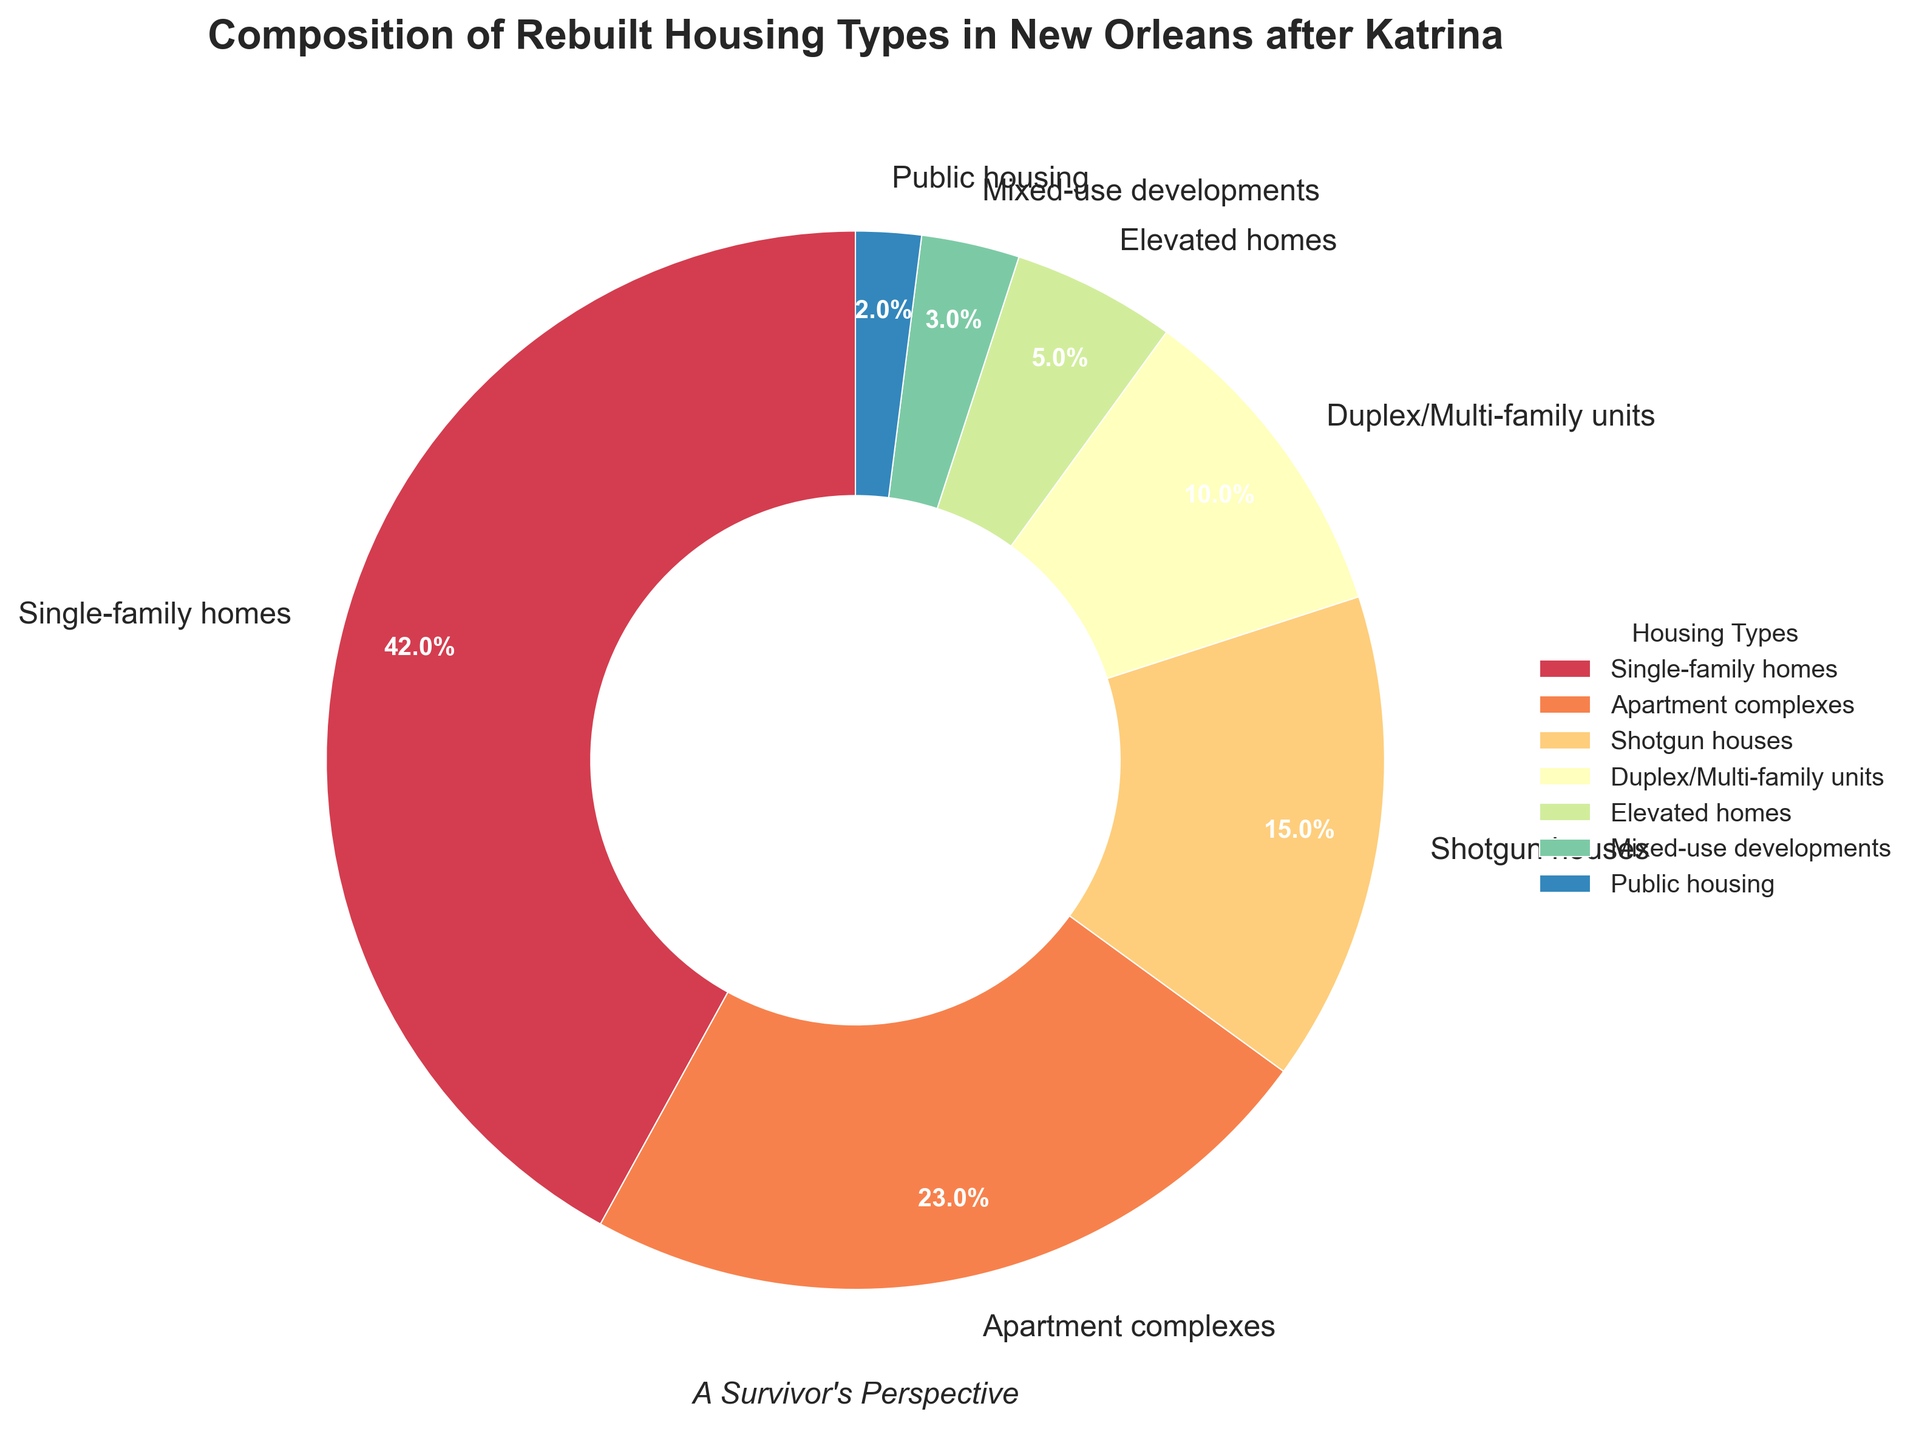Do single-family homes have a higher percentage than apartment complexes? To answer this, check the wedges labeled "Single-family homes" and "Apartment complexes." The percentage for single-family homes is 42%, while apartment complexes are at 23%. Since 42% is greater than 23%, single-family homes have a higher percentage.
Answer: Yes What's the combined percentage of Shotgun houses and Duplex/Multi-family units? Look at the percentages for "Shotgun houses" and "Duplex/Multi-family units." Shotgun houses are at 15%, and Duplex/Multi-family units are at 10%. Their combined percentage is calculated as 15% + 10% = 25%.
Answer: 25% Which housing type has the smallest percentage, and what is it? Check all the wedges to find the one with the smallest percentage. Public housing has the smallest wedge with 2%.
Answer: Public housing, 2% Are there more Shotgun houses or Elevated homes by percentage? Compare the percentages of Shotgun houses and Elevated homes. Shotgun houses are at 15%, while Elevated homes are at 5%. Since 15% is greater than 5%, there are more Shotgun houses.
Answer: Shotgun houses What is the percentage difference between Single-family homes and Mixed-use developments? Subtract the percentage of Mixed-use developments (3%) from Single-family homes (42%). The difference is 42% - 3% = 39%.
Answer: 39% What percentage of the housing types are either Elevated homes or Public housing? Add the percentages of Elevated homes and Public housing. Elevated homes are at 5%, and Public housing is at 2%. Their combined percentage is 5% + 2% = 7%.
Answer: 7% How do Duplex/Multi-family units compare to Apartment complexes in terms of percentage? Duplex/Multi-family units are at 10%, and Apartment complexes are at 23%. Since 10% is less than 23%, Duplex/Multi-family units have a smaller percentage than Apartment complexes.
Answer: Duplex/Multi-family units have a smaller percentage Which housing type has more than twice the percentage of Mixed-use developments? Mixed-use developments are at 3%. Twice this percentage is 3% * 2 = 6%. Housing types with more than 6% include Single-family homes (42%), Apartment complexes (23%), Shotgun houses (15%), and Duplex/Multi-family units (10%).
Answer: Single-family homes, Apartment complexes, Shotgun houses, Duplex/Multi-family units Which two housing types combined have the same percentage as Single-family homes? Single-family homes are at 42%. By looking at the percentages, combining Apartment complexes (23%) and Shotgun houses (15%) gives 23% + 15% = 38%, while adding Duplex/Multi-family units (10%) and Elevated homes (5%) to Shotgun houses (15%) gives 15% + 10% + 5% = 30%. Combining Apartment complexes (23%) and Duplex/Multi-family units (10%) gives 23% + 10% = 33%. None of these combinations exactly match 42%.
Answer: None 